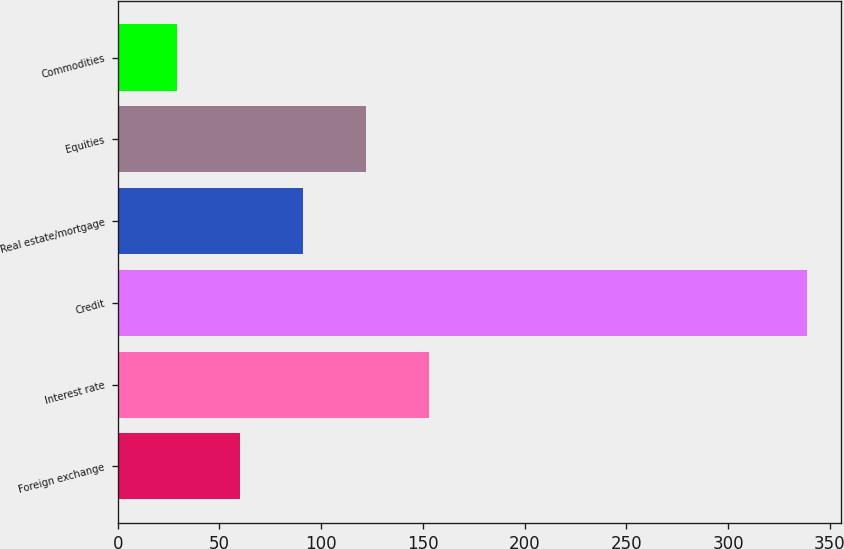Convert chart. <chart><loc_0><loc_0><loc_500><loc_500><bar_chart><fcel>Foreign exchange<fcel>Interest rate<fcel>Credit<fcel>Real estate/mortgage<fcel>Equities<fcel>Commodities<nl><fcel>60.06<fcel>152.94<fcel>338.7<fcel>91.02<fcel>121.98<fcel>29.1<nl></chart> 